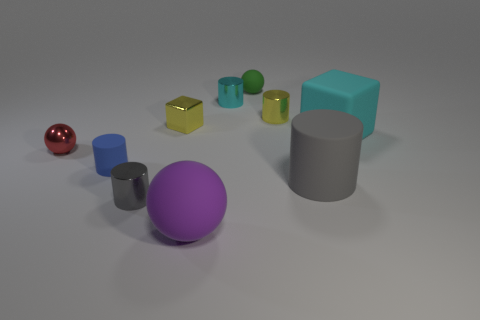Subtract all large spheres. How many spheres are left? 2 Subtract all yellow cylinders. How many cylinders are left? 4 Subtract all spheres. How many objects are left? 7 Subtract all yellow cylinders. How many blue spheres are left? 0 Subtract 2 cylinders. How many cylinders are left? 3 Subtract all purple cylinders. Subtract all red spheres. How many cylinders are left? 5 Subtract all cyan metallic cylinders. Subtract all gray matte cylinders. How many objects are left? 8 Add 9 big gray rubber objects. How many big gray rubber objects are left? 10 Add 6 cyan cylinders. How many cyan cylinders exist? 7 Subtract 1 blue cylinders. How many objects are left? 9 